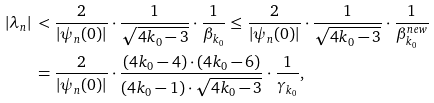<formula> <loc_0><loc_0><loc_500><loc_500>| \lambda _ { n } | & \, < \frac { 2 } { | \psi _ { n } ( 0 ) | } \cdot \frac { 1 } { \sqrt { 4 k _ { 0 } - 3 } } \cdot \frac { 1 } { \beta _ { k _ { 0 } } } \leq \frac { 2 } { | \psi _ { n } ( 0 ) | } \cdot \frac { 1 } { \sqrt { 4 k _ { 0 } - 3 } } \cdot \frac { 1 } { \beta ^ { n e w } _ { k _ { 0 } } } \\ & \, = \frac { 2 } { | \psi _ { n } ( 0 ) | } \cdot \frac { ( 4 k _ { 0 } - 4 ) \cdot ( 4 k _ { 0 } - 6 ) } { ( 4 k _ { 0 } - 1 ) \cdot \sqrt { 4 k _ { 0 } - 3 } } \cdot \frac { 1 } { \gamma _ { k _ { 0 } } } ,</formula> 